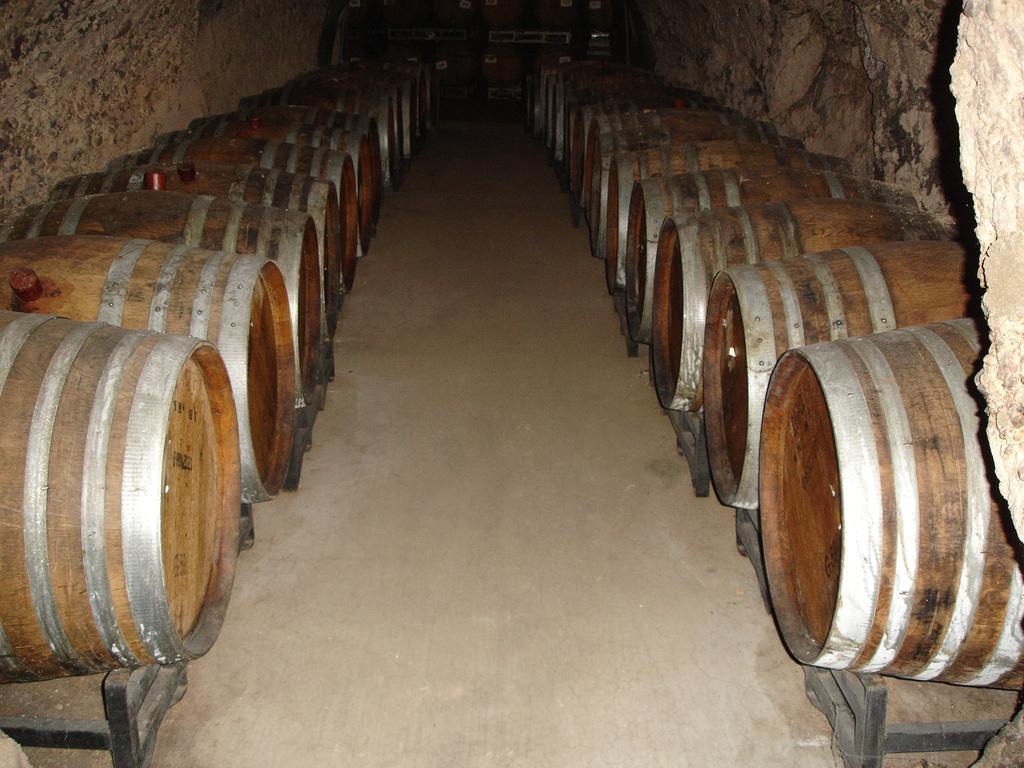In one or two sentences, can you explain what this image depicts? In this picture we can see few barrels on the stands. 